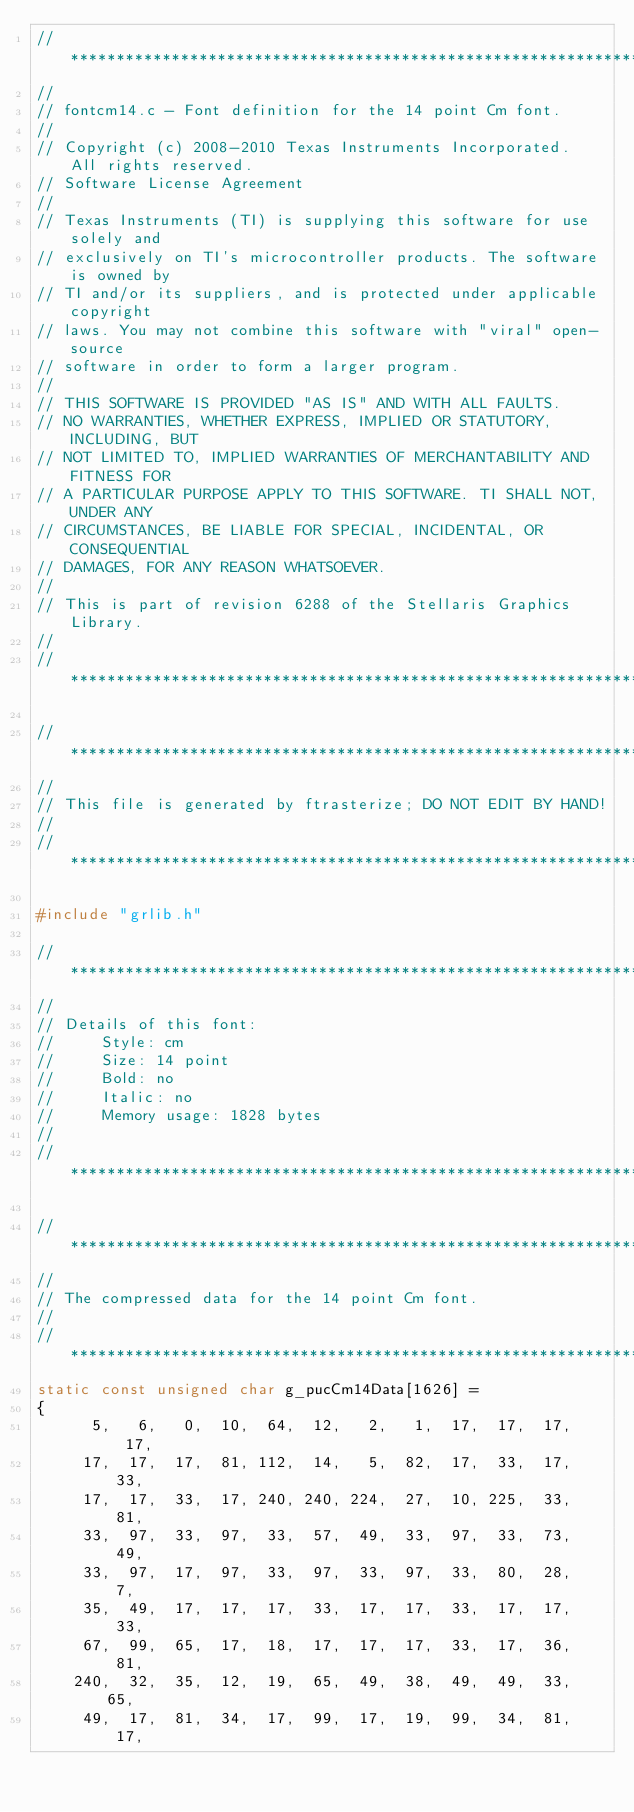<code> <loc_0><loc_0><loc_500><loc_500><_C_>//*****************************************************************************
//
// fontcm14.c - Font definition for the 14 point Cm font.
//
// Copyright (c) 2008-2010 Texas Instruments Incorporated.  All rights reserved.
// Software License Agreement
//
// Texas Instruments (TI) is supplying this software for use solely and
// exclusively on TI's microcontroller products. The software is owned by
// TI and/or its suppliers, and is protected under applicable copyright
// laws. You may not combine this software with "viral" open-source
// software in order to form a larger program.
//
// THIS SOFTWARE IS PROVIDED "AS IS" AND WITH ALL FAULTS.
// NO WARRANTIES, WHETHER EXPRESS, IMPLIED OR STATUTORY, INCLUDING, BUT
// NOT LIMITED TO, IMPLIED WARRANTIES OF MERCHANTABILITY AND FITNESS FOR
// A PARTICULAR PURPOSE APPLY TO THIS SOFTWARE. TI SHALL NOT, UNDER ANY
// CIRCUMSTANCES, BE LIABLE FOR SPECIAL, INCIDENTAL, OR CONSEQUENTIAL
// DAMAGES, FOR ANY REASON WHATSOEVER.
//
// This is part of revision 6288 of the Stellaris Graphics Library.
//
//*****************************************************************************

//*****************************************************************************
//
// This file is generated by ftrasterize; DO NOT EDIT BY HAND!
//
//*****************************************************************************

#include "grlib.h"

//*****************************************************************************
//
// Details of this font:
//     Style: cm
//     Size: 14 point
//     Bold: no
//     Italic: no
//     Memory usage: 1828 bytes
//
//*****************************************************************************

//*****************************************************************************
//
// The compressed data for the 14 point Cm font.
//
//*****************************************************************************
static const unsigned char g_pucCm14Data[1626] =
{
      5,   6,   0,  10,  64,  12,   2,   1,  17,  17,  17,  17,
     17,  17,  17,  81, 112,  14,   5,  82,  17,  33,  17,  33,
     17,  17,  33,  17, 240, 240, 224,  27,  10, 225,  33,  81,
     33,  97,  33,  97,  33,  57,  49,  33,  97,  33,  73,  49,
     33,  97,  17,  97,  33,  97,  33,  97,  33,  80,  28,   7,
     35,  49,  17,  17,  17,  33,  17,  17,  33,  17,  17,  33,
     67,  99,  65,  17,  18,  17,  17,  17,  33,  17,  36,  81,
    240,  32,  35,  12,  19,  65,  49,  38,  49,  49,  33,  65,
     49,  17,  81,  34,  17,  99,  17,  19,  99,  34,  81,  17,</code> 